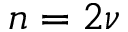<formula> <loc_0><loc_0><loc_500><loc_500>n = 2 \nu</formula> 